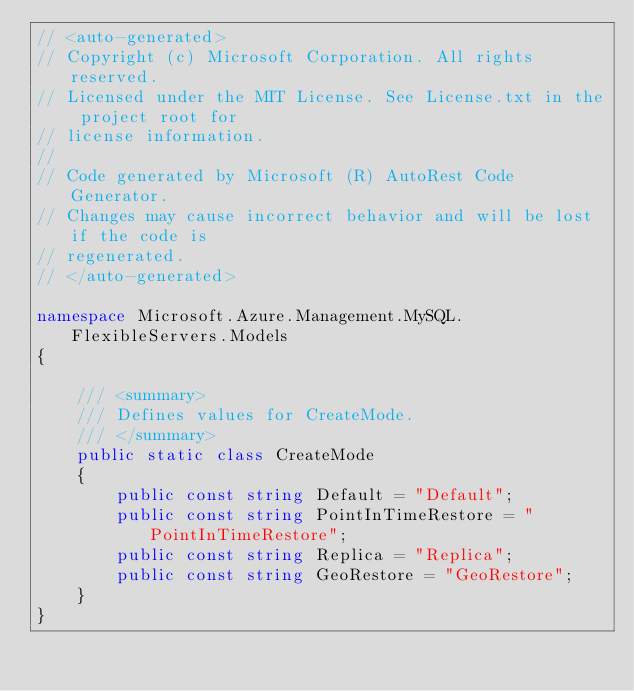<code> <loc_0><loc_0><loc_500><loc_500><_C#_>// <auto-generated>
// Copyright (c) Microsoft Corporation. All rights reserved.
// Licensed under the MIT License. See License.txt in the project root for
// license information.
//
// Code generated by Microsoft (R) AutoRest Code Generator.
// Changes may cause incorrect behavior and will be lost if the code is
// regenerated.
// </auto-generated>

namespace Microsoft.Azure.Management.MySQL.FlexibleServers.Models
{

    /// <summary>
    /// Defines values for CreateMode.
    /// </summary>
    public static class CreateMode
    {
        public const string Default = "Default";
        public const string PointInTimeRestore = "PointInTimeRestore";
        public const string Replica = "Replica";
        public const string GeoRestore = "GeoRestore";
    }
}
</code> 